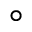Convert formula to latex. <formula><loc_0><loc_0><loc_500><loc_500>^ { \circ }</formula> 